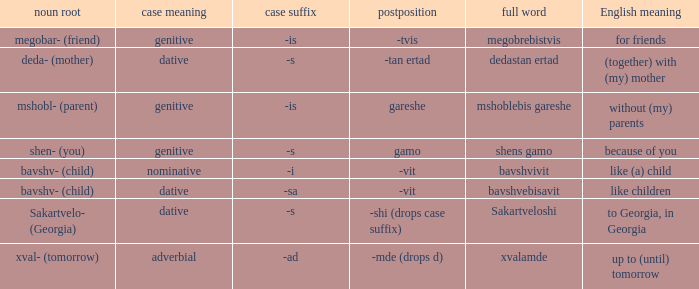What is English Meaning, when Case Suffix (Case) is "-sa (dative)"? Like children. 